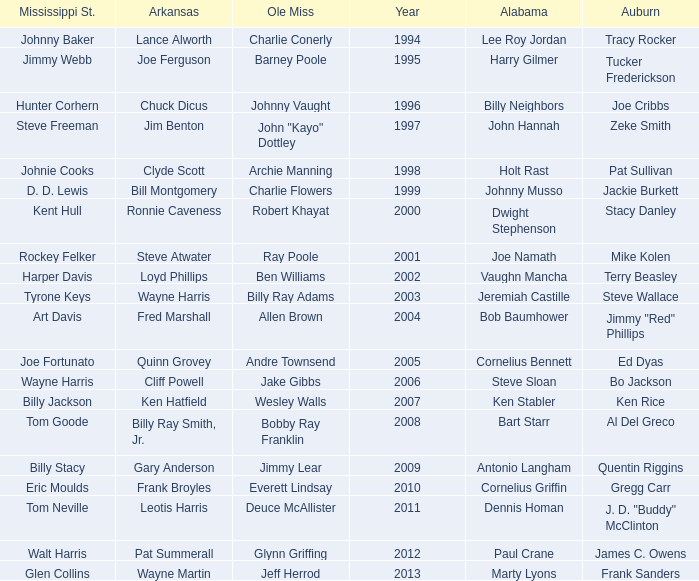Who was the Alabama player associated with Walt Harris? Paul Crane. 